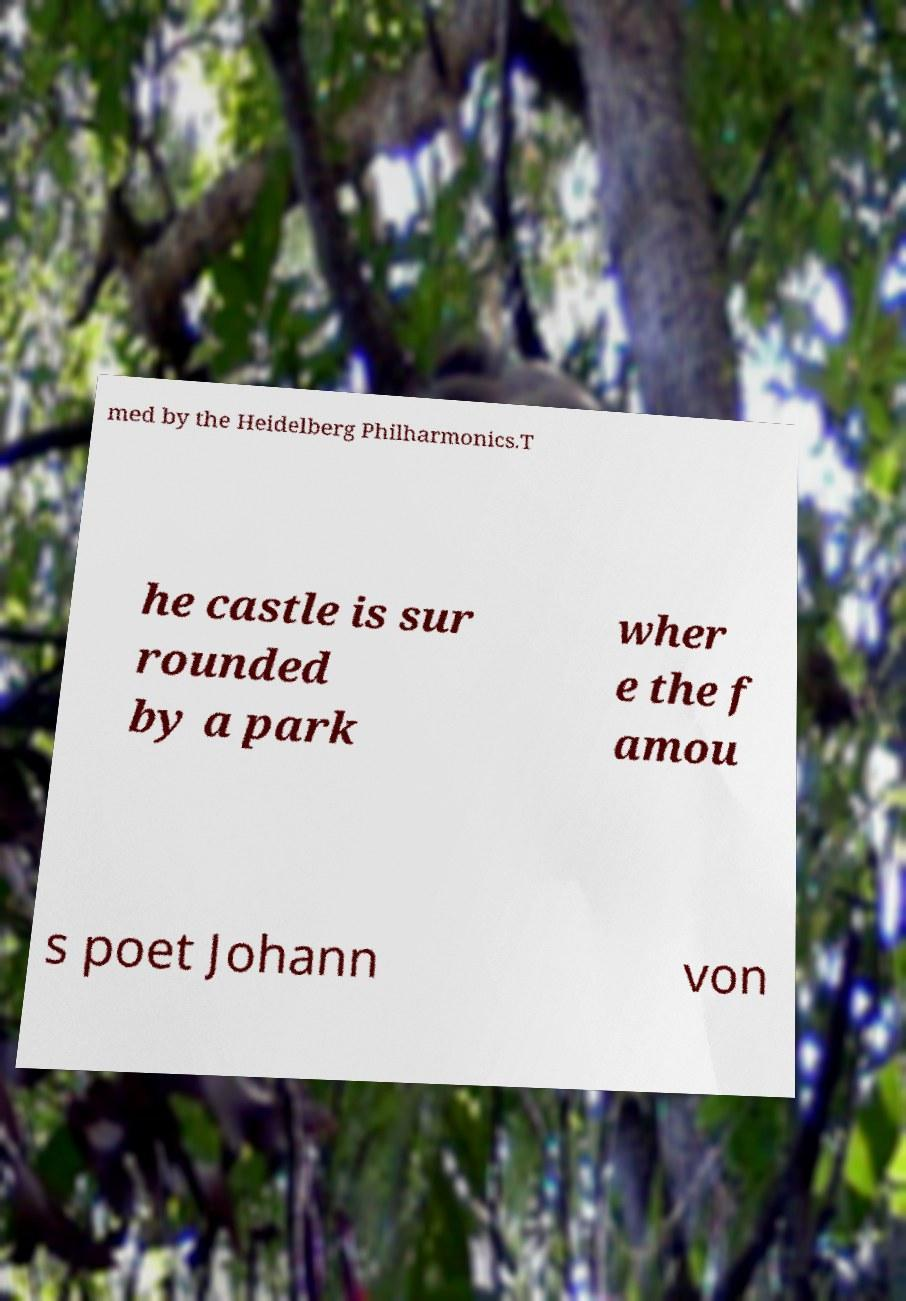Could you assist in decoding the text presented in this image and type it out clearly? med by the Heidelberg Philharmonics.T he castle is sur rounded by a park wher e the f amou s poet Johann von 